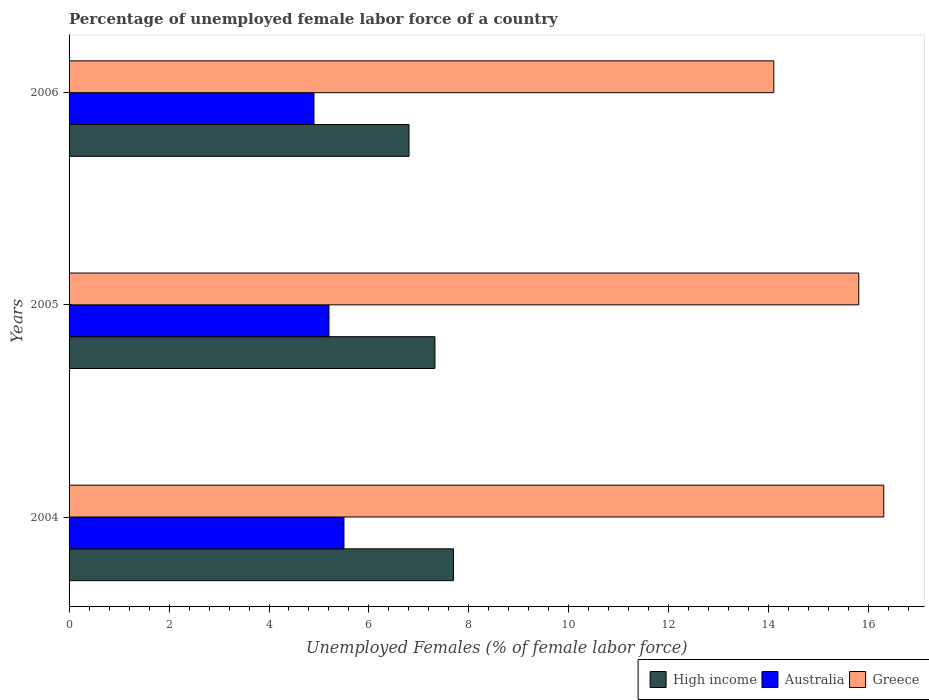How many different coloured bars are there?
Your response must be concise. 3. How many bars are there on the 3rd tick from the top?
Your answer should be very brief. 3. How many bars are there on the 3rd tick from the bottom?
Your response must be concise. 3. In how many cases, is the number of bars for a given year not equal to the number of legend labels?
Provide a short and direct response. 0. What is the percentage of unemployed female labor force in Greece in 2006?
Your answer should be very brief. 14.1. Across all years, what is the maximum percentage of unemployed female labor force in High income?
Your answer should be very brief. 7.69. Across all years, what is the minimum percentage of unemployed female labor force in Australia?
Provide a short and direct response. 4.9. In which year was the percentage of unemployed female labor force in High income minimum?
Ensure brevity in your answer.  2006. What is the total percentage of unemployed female labor force in Greece in the graph?
Offer a terse response. 46.2. What is the difference between the percentage of unemployed female labor force in High income in 2005 and that in 2006?
Ensure brevity in your answer.  0.52. What is the difference between the percentage of unemployed female labor force in Australia in 2004 and the percentage of unemployed female labor force in High income in 2006?
Give a very brief answer. -1.3. What is the average percentage of unemployed female labor force in Australia per year?
Provide a succinct answer. 5.2. In the year 2004, what is the difference between the percentage of unemployed female labor force in Australia and percentage of unemployed female labor force in High income?
Offer a terse response. -2.19. What is the ratio of the percentage of unemployed female labor force in High income in 2004 to that in 2006?
Provide a succinct answer. 1.13. Is the percentage of unemployed female labor force in High income in 2004 less than that in 2006?
Offer a very short reply. No. What is the difference between the highest and the second highest percentage of unemployed female labor force in Australia?
Ensure brevity in your answer.  0.3. What is the difference between the highest and the lowest percentage of unemployed female labor force in High income?
Ensure brevity in your answer.  0.89. Is the sum of the percentage of unemployed female labor force in Greece in 2005 and 2006 greater than the maximum percentage of unemployed female labor force in Australia across all years?
Offer a very short reply. Yes. Is it the case that in every year, the sum of the percentage of unemployed female labor force in High income and percentage of unemployed female labor force in Australia is greater than the percentage of unemployed female labor force in Greece?
Offer a very short reply. No. How many bars are there?
Offer a terse response. 9. How many years are there in the graph?
Offer a very short reply. 3. How many legend labels are there?
Keep it short and to the point. 3. How are the legend labels stacked?
Your answer should be very brief. Horizontal. What is the title of the graph?
Your response must be concise. Percentage of unemployed female labor force of a country. What is the label or title of the X-axis?
Offer a very short reply. Unemployed Females (% of female labor force). What is the Unemployed Females (% of female labor force) of High income in 2004?
Keep it short and to the point. 7.69. What is the Unemployed Females (% of female labor force) in Greece in 2004?
Make the answer very short. 16.3. What is the Unemployed Females (% of female labor force) of High income in 2005?
Make the answer very short. 7.32. What is the Unemployed Females (% of female labor force) of Australia in 2005?
Provide a succinct answer. 5.2. What is the Unemployed Females (% of female labor force) in Greece in 2005?
Provide a succinct answer. 15.8. What is the Unemployed Females (% of female labor force) of High income in 2006?
Offer a very short reply. 6.8. What is the Unemployed Females (% of female labor force) of Australia in 2006?
Offer a very short reply. 4.9. What is the Unemployed Females (% of female labor force) in Greece in 2006?
Your answer should be very brief. 14.1. Across all years, what is the maximum Unemployed Females (% of female labor force) of High income?
Provide a succinct answer. 7.69. Across all years, what is the maximum Unemployed Females (% of female labor force) in Greece?
Ensure brevity in your answer.  16.3. Across all years, what is the minimum Unemployed Females (% of female labor force) of High income?
Offer a very short reply. 6.8. Across all years, what is the minimum Unemployed Females (% of female labor force) of Australia?
Offer a terse response. 4.9. Across all years, what is the minimum Unemployed Females (% of female labor force) in Greece?
Give a very brief answer. 14.1. What is the total Unemployed Females (% of female labor force) of High income in the graph?
Keep it short and to the point. 21.81. What is the total Unemployed Females (% of female labor force) in Greece in the graph?
Keep it short and to the point. 46.2. What is the difference between the Unemployed Females (% of female labor force) in High income in 2004 and that in 2005?
Offer a terse response. 0.37. What is the difference between the Unemployed Females (% of female labor force) in High income in 2004 and that in 2006?
Your response must be concise. 0.89. What is the difference between the Unemployed Females (% of female labor force) in Australia in 2004 and that in 2006?
Keep it short and to the point. 0.6. What is the difference between the Unemployed Females (% of female labor force) of Greece in 2004 and that in 2006?
Offer a very short reply. 2.2. What is the difference between the Unemployed Females (% of female labor force) of High income in 2005 and that in 2006?
Provide a short and direct response. 0.52. What is the difference between the Unemployed Females (% of female labor force) in Australia in 2005 and that in 2006?
Your answer should be very brief. 0.3. What is the difference between the Unemployed Females (% of female labor force) of High income in 2004 and the Unemployed Females (% of female labor force) of Australia in 2005?
Keep it short and to the point. 2.49. What is the difference between the Unemployed Females (% of female labor force) in High income in 2004 and the Unemployed Females (% of female labor force) in Greece in 2005?
Your answer should be very brief. -8.11. What is the difference between the Unemployed Females (% of female labor force) in High income in 2004 and the Unemployed Females (% of female labor force) in Australia in 2006?
Your answer should be very brief. 2.79. What is the difference between the Unemployed Females (% of female labor force) in High income in 2004 and the Unemployed Females (% of female labor force) in Greece in 2006?
Make the answer very short. -6.41. What is the difference between the Unemployed Females (% of female labor force) of Australia in 2004 and the Unemployed Females (% of female labor force) of Greece in 2006?
Provide a succinct answer. -8.6. What is the difference between the Unemployed Females (% of female labor force) in High income in 2005 and the Unemployed Females (% of female labor force) in Australia in 2006?
Make the answer very short. 2.42. What is the difference between the Unemployed Females (% of female labor force) of High income in 2005 and the Unemployed Females (% of female labor force) of Greece in 2006?
Keep it short and to the point. -6.78. What is the difference between the Unemployed Females (% of female labor force) of Australia in 2005 and the Unemployed Females (% of female labor force) of Greece in 2006?
Give a very brief answer. -8.9. What is the average Unemployed Females (% of female labor force) of High income per year?
Give a very brief answer. 7.27. What is the average Unemployed Females (% of female labor force) of Greece per year?
Offer a very short reply. 15.4. In the year 2004, what is the difference between the Unemployed Females (% of female labor force) of High income and Unemployed Females (% of female labor force) of Australia?
Give a very brief answer. 2.19. In the year 2004, what is the difference between the Unemployed Females (% of female labor force) of High income and Unemployed Females (% of female labor force) of Greece?
Give a very brief answer. -8.61. In the year 2004, what is the difference between the Unemployed Females (% of female labor force) in Australia and Unemployed Females (% of female labor force) in Greece?
Your response must be concise. -10.8. In the year 2005, what is the difference between the Unemployed Females (% of female labor force) of High income and Unemployed Females (% of female labor force) of Australia?
Your response must be concise. 2.12. In the year 2005, what is the difference between the Unemployed Females (% of female labor force) of High income and Unemployed Females (% of female labor force) of Greece?
Make the answer very short. -8.48. In the year 2006, what is the difference between the Unemployed Females (% of female labor force) in High income and Unemployed Females (% of female labor force) in Australia?
Your response must be concise. 1.9. In the year 2006, what is the difference between the Unemployed Females (% of female labor force) in High income and Unemployed Females (% of female labor force) in Greece?
Your answer should be compact. -7.3. In the year 2006, what is the difference between the Unemployed Females (% of female labor force) in Australia and Unemployed Females (% of female labor force) in Greece?
Keep it short and to the point. -9.2. What is the ratio of the Unemployed Females (% of female labor force) in High income in 2004 to that in 2005?
Make the answer very short. 1.05. What is the ratio of the Unemployed Females (% of female labor force) of Australia in 2004 to that in 2005?
Provide a succinct answer. 1.06. What is the ratio of the Unemployed Females (% of female labor force) of Greece in 2004 to that in 2005?
Offer a very short reply. 1.03. What is the ratio of the Unemployed Females (% of female labor force) in High income in 2004 to that in 2006?
Provide a succinct answer. 1.13. What is the ratio of the Unemployed Females (% of female labor force) of Australia in 2004 to that in 2006?
Provide a short and direct response. 1.12. What is the ratio of the Unemployed Females (% of female labor force) in Greece in 2004 to that in 2006?
Provide a succinct answer. 1.16. What is the ratio of the Unemployed Females (% of female labor force) in High income in 2005 to that in 2006?
Keep it short and to the point. 1.08. What is the ratio of the Unemployed Females (% of female labor force) in Australia in 2005 to that in 2006?
Ensure brevity in your answer.  1.06. What is the ratio of the Unemployed Females (% of female labor force) of Greece in 2005 to that in 2006?
Keep it short and to the point. 1.12. What is the difference between the highest and the second highest Unemployed Females (% of female labor force) in High income?
Make the answer very short. 0.37. What is the difference between the highest and the second highest Unemployed Females (% of female labor force) of Greece?
Make the answer very short. 0.5. What is the difference between the highest and the lowest Unemployed Females (% of female labor force) of High income?
Provide a short and direct response. 0.89. What is the difference between the highest and the lowest Unemployed Females (% of female labor force) of Greece?
Your answer should be very brief. 2.2. 